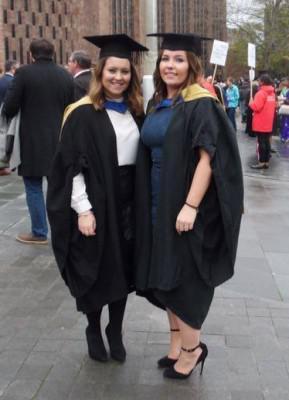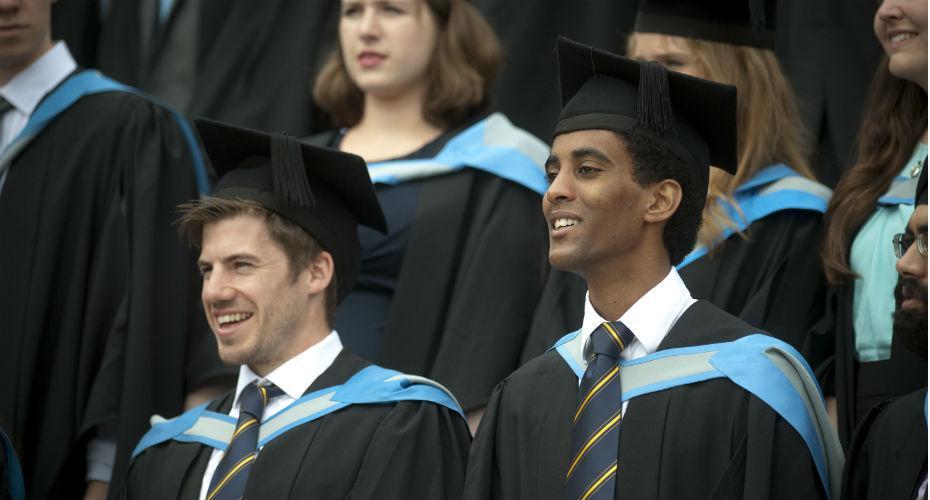The first image is the image on the left, the second image is the image on the right. Examine the images to the left and right. Is the description "Two graduates stand together outside posing for a picture in the image on the left." accurate? Answer yes or no. Yes. The first image is the image on the left, the second image is the image on the right. For the images shown, is this caption "The right image shows multiple black-robed graduates wearing caps and  bright sky-blue sashes." true? Answer yes or no. Yes. 